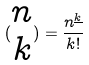Convert formula to latex. <formula><loc_0><loc_0><loc_500><loc_500>( \begin{matrix} n \\ k \end{matrix} ) = \frac { n ^ { \underline { k } } } { k ! }</formula> 